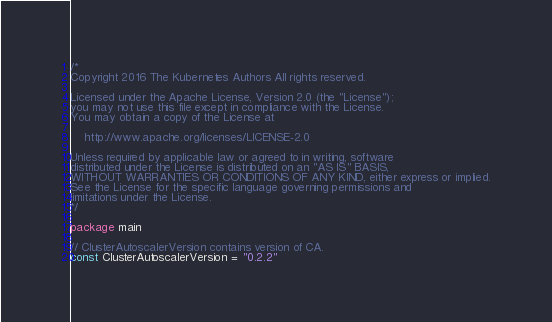Convert code to text. <code><loc_0><loc_0><loc_500><loc_500><_Go_>/*
Copyright 2016 The Kubernetes Authors All rights reserved.

Licensed under the Apache License, Version 2.0 (the "License");
you may not use this file except in compliance with the License.
You may obtain a copy of the License at

    http://www.apache.org/licenses/LICENSE-2.0

Unless required by applicable law or agreed to in writing, software
distributed under the License is distributed on an "AS IS" BASIS,
WITHOUT WARRANTIES OR CONDITIONS OF ANY KIND, either express or implied.
See the License for the specific language governing permissions and
limitations under the License.
*/

package main

// ClusterAutoscalerVersion contains version of CA.
const ClusterAutoscalerVersion = "0.2.2"
</code> 